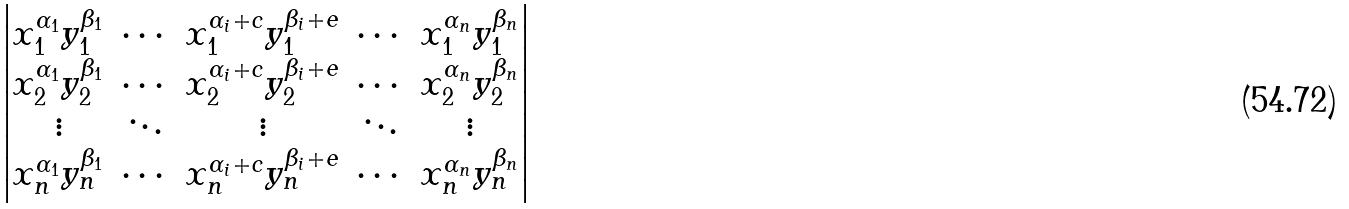<formula> <loc_0><loc_0><loc_500><loc_500>\begin{vmatrix} x _ { 1 } ^ { \alpha _ { 1 } } y _ { 1 } ^ { \beta _ { 1 } } & \cdots & x _ { 1 } ^ { \alpha _ { i } + c } y _ { 1 } ^ { \beta _ { i } + e } & \cdots & x _ { 1 } ^ { \alpha _ { n } } y _ { 1 } ^ { \beta _ { n } } \\ x _ { 2 } ^ { \alpha _ { 1 } } y _ { 2 } ^ { \beta _ { 1 } } & \cdots & x _ { 2 } ^ { \alpha _ { i } + c } y _ { 2 } ^ { \beta _ { i } + e } & \cdots & x _ { 2 } ^ { \alpha _ { n } } y _ { 2 } ^ { \beta _ { n } } \\ \vdots & \ddots & \vdots & \ddots & \vdots \\ x _ { n } ^ { \alpha _ { 1 } } y _ { n } ^ { \beta _ { 1 } } & \cdots & x _ { n } ^ { \alpha _ { i } + c } y _ { n } ^ { \beta _ { i } + e } & \cdots & x _ { n } ^ { \alpha _ { n } } y _ { n } ^ { \beta _ { n } } \\ \end{vmatrix}</formula> 